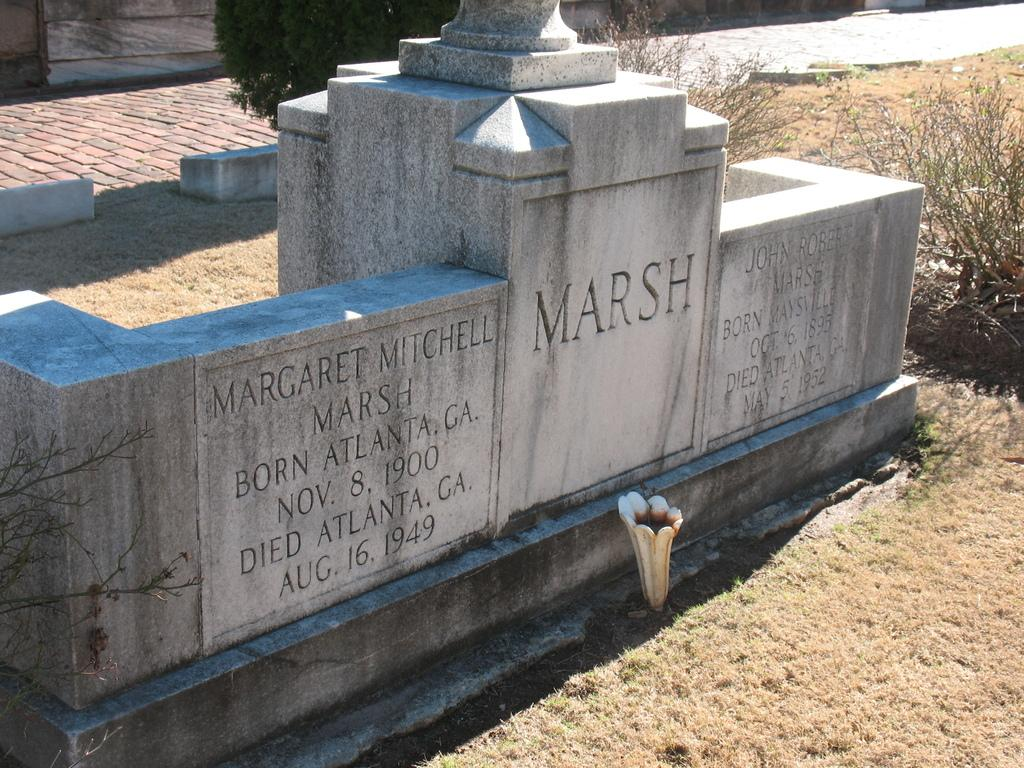What is the main subject in the center of the image? There is a graveyard in the center of the image. What can be seen in the background of the image? There are plants in the background of the image. What is located at the bottom of the image? There is a road at the bottom of the image. What type of glue is used to hold the servant's hat in the image? There is no servant or hat present in the image, so it is not possible to determine what type of glue might be used. 